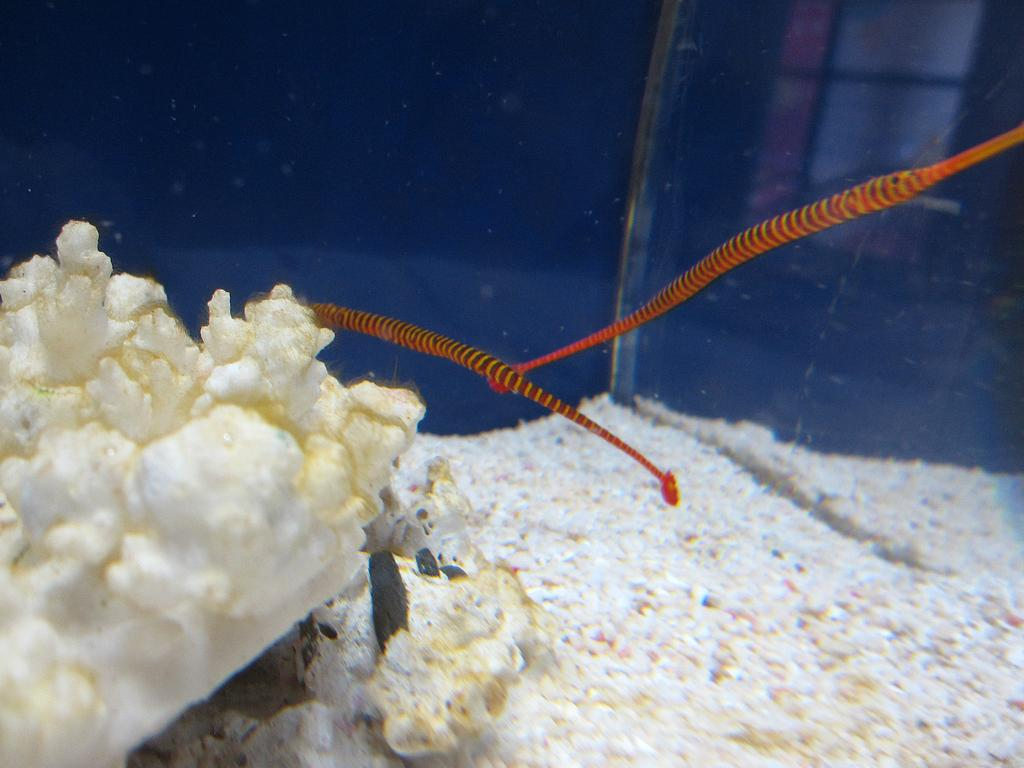What type of underwater landscape is depicted in the image? The image features corals, sand particles, and water, suggesting an underwater scene. What other marine life can be seen in the image? Fish are present in the image. What is the texture of the ground in the image? Sand particles are visible in the image, indicating a sandy texture. What type of furniture is present in the image? There is no furniture present in the image; it features an underwater scene with corals, sand particles, water, and fish. What level of detail can be seen in the corals in the image? The image does not provide a specific level of detail for the corals; it simply shows their presence in the underwater landscape. 